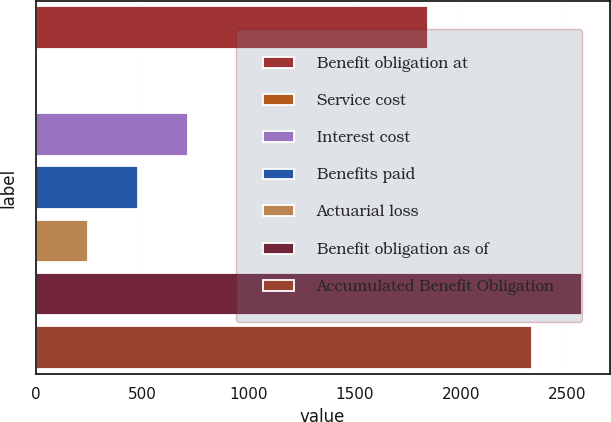Convert chart to OTSL. <chart><loc_0><loc_0><loc_500><loc_500><bar_chart><fcel>Benefit obligation at<fcel>Service cost<fcel>Interest cost<fcel>Benefits paid<fcel>Actuarial loss<fcel>Benefit obligation as of<fcel>Accumulated Benefit Obligation<nl><fcel>1844<fcel>8<fcel>715.4<fcel>479.6<fcel>243.8<fcel>2569.8<fcel>2334<nl></chart> 